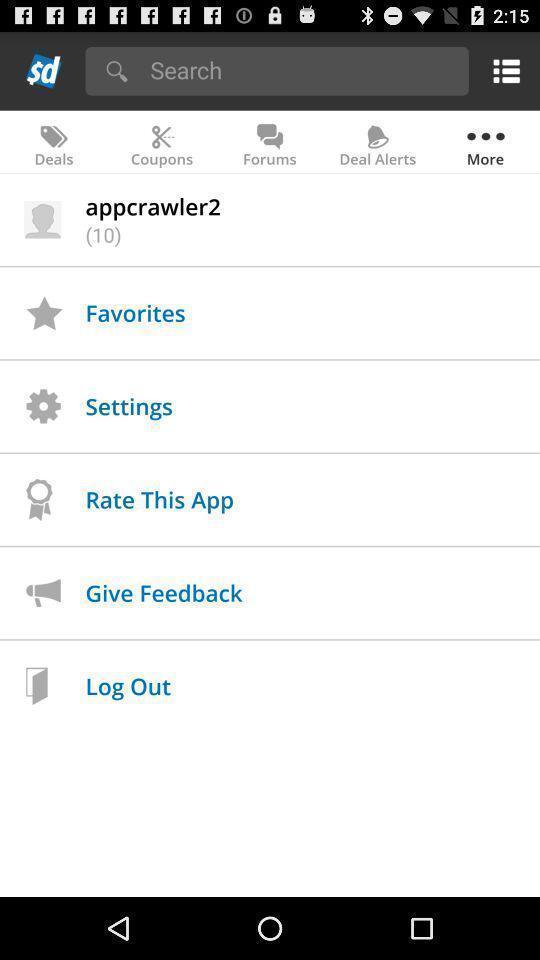Provide a textual representation of this image. Search page with different app functions in the deals app. 